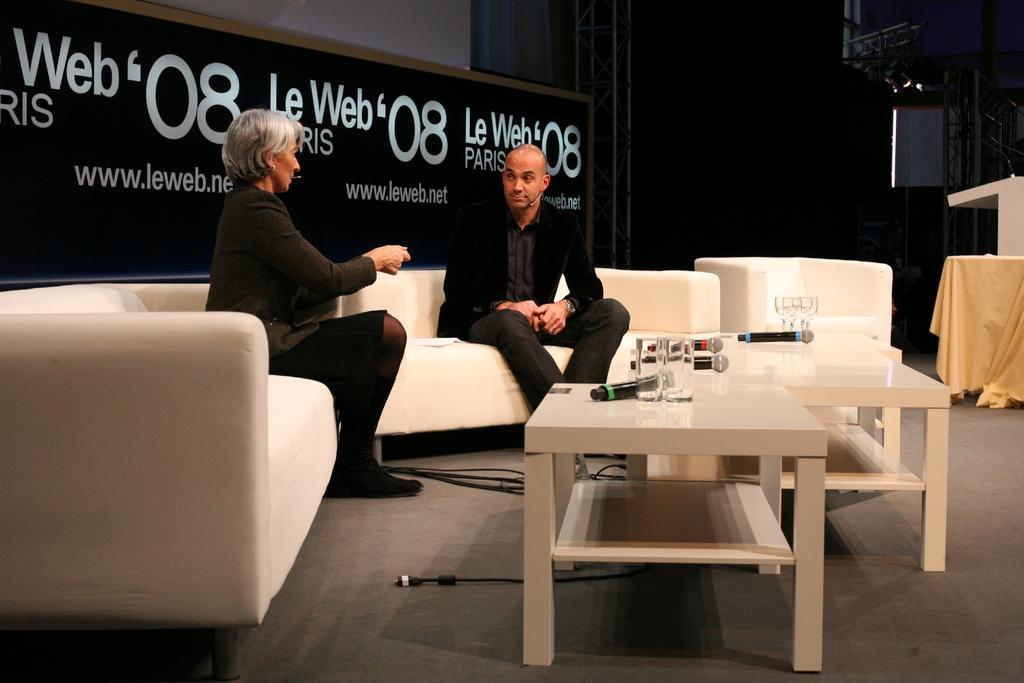Can you describe this image briefly? In this image there are two people who are sitting on the sofa. In front of them there is a table on which there are mics and two glasses. At the back side there is a hoarding on which some words are written. To the right side there is a curtain. At the back side there is a stand. 